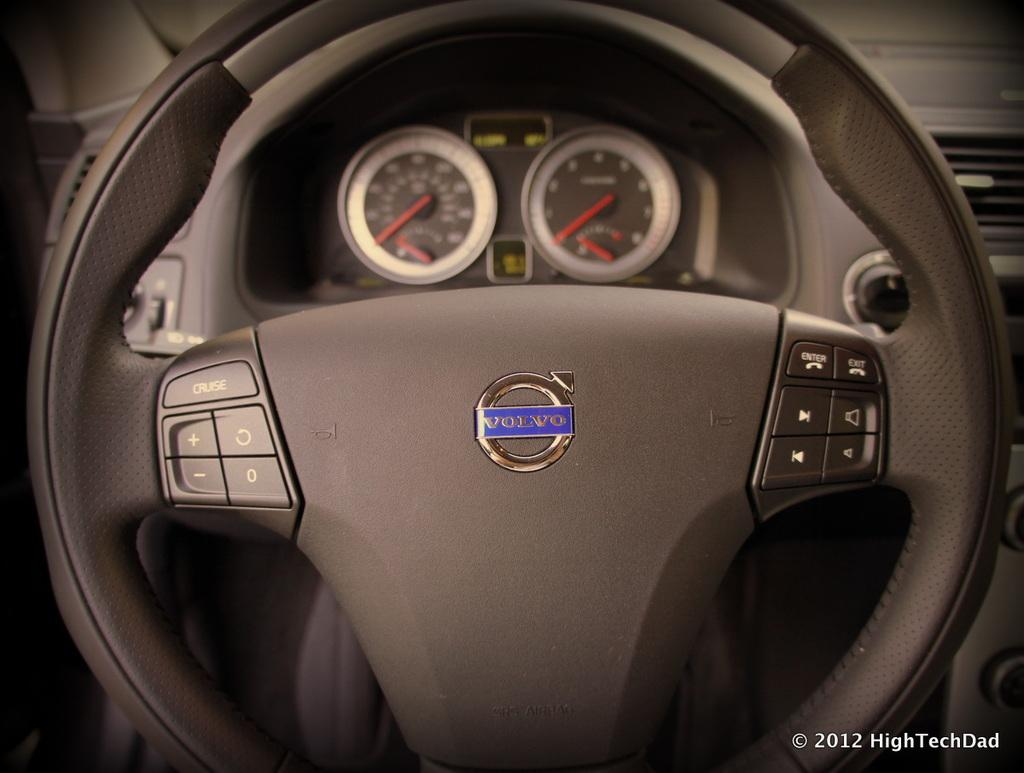What is the main subject of the image? The main subject of the image is the steering of a car with buttons. Are there any identifiable symbols or designs in the image? Yes, there is a logo in the image. What additional information can be found on the steering wheel? There are meters visible in the image. Is there any text present in the image? Yes, there is text written in the right bottom corner of the image. Can you describe the bubble that the boy is blowing in the image? There is no bubble or boy present in the image; it features the steering wheel of a car with buttons, a logo, meters, and text. 